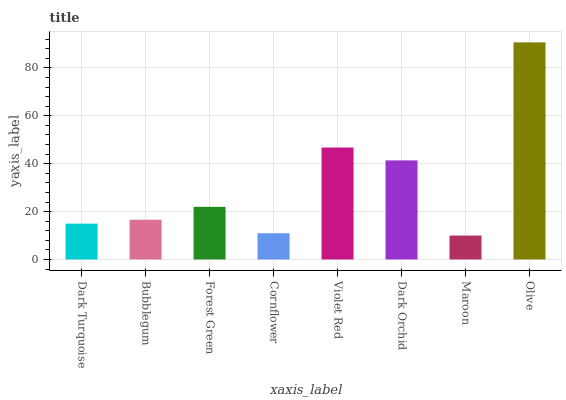Is Bubblegum the minimum?
Answer yes or no. No. Is Bubblegum the maximum?
Answer yes or no. No. Is Bubblegum greater than Dark Turquoise?
Answer yes or no. Yes. Is Dark Turquoise less than Bubblegum?
Answer yes or no. Yes. Is Dark Turquoise greater than Bubblegum?
Answer yes or no. No. Is Bubblegum less than Dark Turquoise?
Answer yes or no. No. Is Forest Green the high median?
Answer yes or no. Yes. Is Bubblegum the low median?
Answer yes or no. Yes. Is Dark Orchid the high median?
Answer yes or no. No. Is Forest Green the low median?
Answer yes or no. No. 